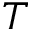Convert formula to latex. <formula><loc_0><loc_0><loc_500><loc_500>T</formula> 